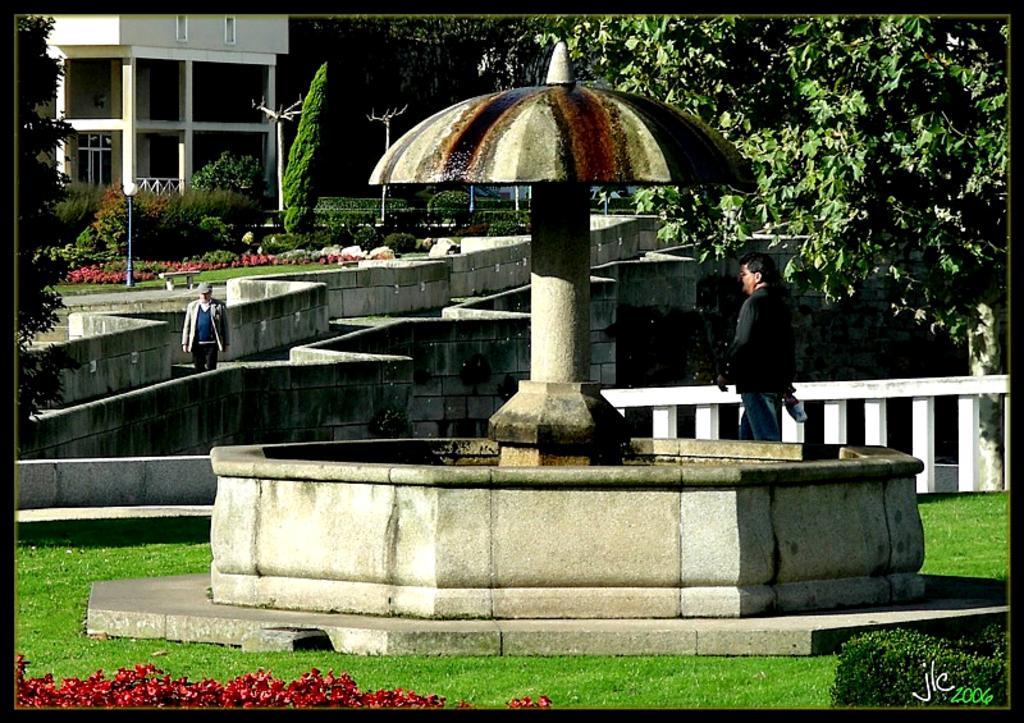In one or two sentences, can you explain what this image depicts? In this image we can see a fountain, plants and grass on the ground, a person at the fence. In the background we can see a person, plants and grass on the ground, trees and a building. 